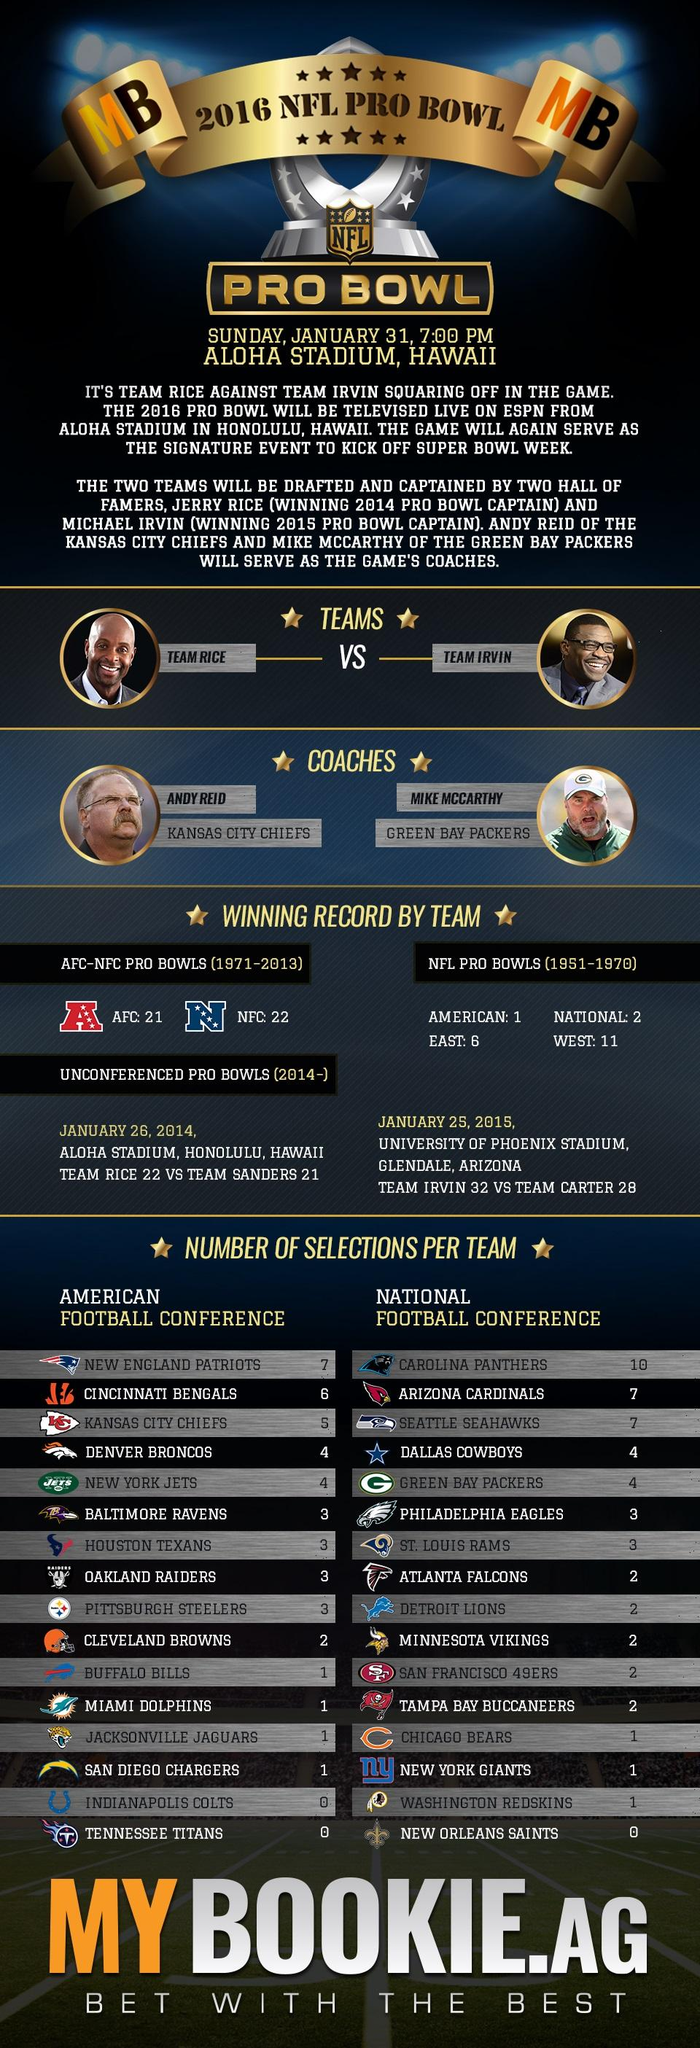Specify some key components in this picture. The National Football Conference (NFC) has won more games in the Pro Bowl during the years 1971-2013. The American Football Conference, commonly referred to as the AFC, is a professional football league that operates in the United States and Canada. During the period of 1971 to 2013, the National Football Conference (NFC) won a total of 22 games in Pro Bowls. The coach of the Green Bay Packers during the 2016 NFL Pro Bowl was MIKE MCCARTHY. There are 16 teams in the American Football Conference (AFC). 